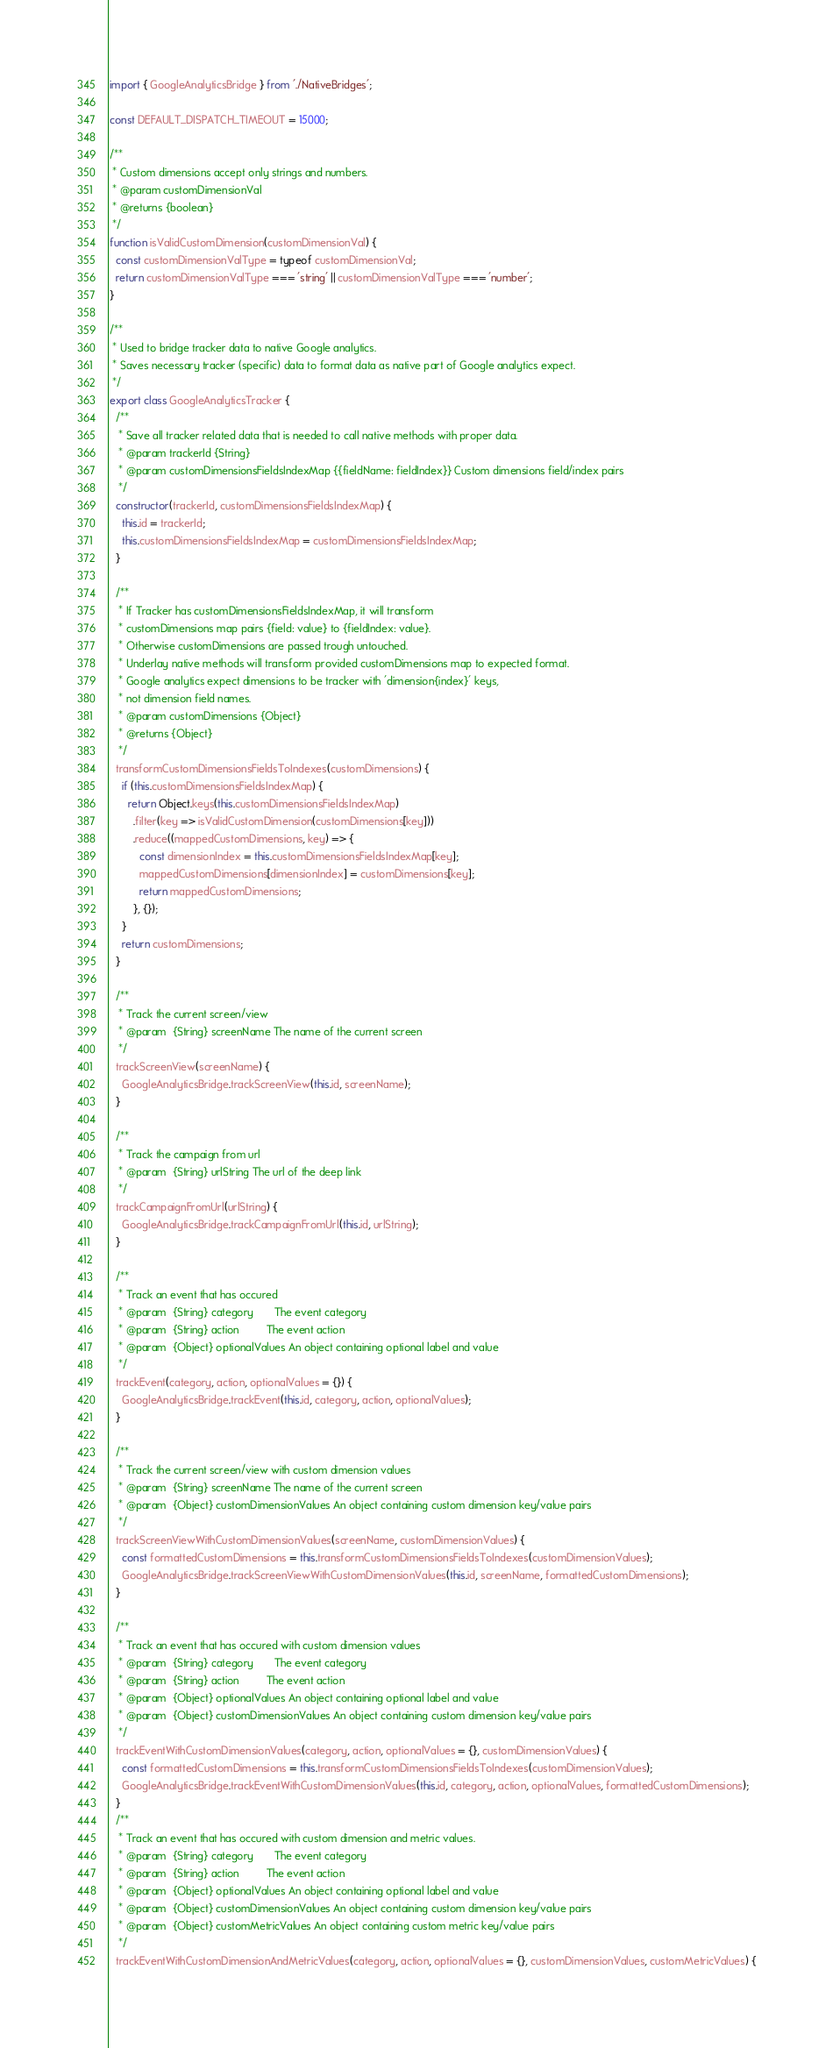Convert code to text. <code><loc_0><loc_0><loc_500><loc_500><_JavaScript_>import { GoogleAnalyticsBridge } from './NativeBridges';

const DEFAULT_DISPATCH_TIMEOUT = 15000;

/**
 * Custom dimensions accept only strings and numbers.
 * @param customDimensionVal
 * @returns {boolean}
 */
function isValidCustomDimension(customDimensionVal) {
  const customDimensionValType = typeof customDimensionVal;
  return customDimensionValType === 'string' || customDimensionValType === 'number';
}

/**
 * Used to bridge tracker data to native Google analytics.
 * Saves necessary tracker (specific) data to format data as native part of Google analytics expect.
 */
export class GoogleAnalyticsTracker {
  /**
   * Save all tracker related data that is needed to call native methods with proper data.
   * @param trackerId {String}
   * @param customDimensionsFieldsIndexMap {{fieldName: fieldIndex}} Custom dimensions field/index pairs
   */
  constructor(trackerId, customDimensionsFieldsIndexMap) {
    this.id = trackerId;
    this.customDimensionsFieldsIndexMap = customDimensionsFieldsIndexMap;
  }

  /**
   * If Tracker has customDimensionsFieldsIndexMap, it will transform
   * customDimensions map pairs {field: value} to {fieldIndex: value}.
   * Otherwise customDimensions are passed trough untouched.
   * Underlay native methods will transform provided customDimensions map to expected format.
   * Google analytics expect dimensions to be tracker with 'dimension{index}' keys,
   * not dimension field names.
   * @param customDimensions {Object}
   * @returns {Object}
   */
  transformCustomDimensionsFieldsToIndexes(customDimensions) {
    if (this.customDimensionsFieldsIndexMap) {
      return Object.keys(this.customDimensionsFieldsIndexMap)
        .filter(key => isValidCustomDimension(customDimensions[key]))
        .reduce((mappedCustomDimensions, key) => {
          const dimensionIndex = this.customDimensionsFieldsIndexMap[key];
          mappedCustomDimensions[dimensionIndex] = customDimensions[key];
          return mappedCustomDimensions;
        }, {});
    }
    return customDimensions;
  }

  /**
   * Track the current screen/view
   * @param  {String} screenName The name of the current screen
   */
  trackScreenView(screenName) {
    GoogleAnalyticsBridge.trackScreenView(this.id, screenName);
  }

  /**
   * Track the campaign from url
   * @param  {String} urlString The url of the deep link
   */
  trackCampaignFromUrl(urlString) {
    GoogleAnalyticsBridge.trackCampaignFromUrl(this.id, urlString);
  }

  /**
   * Track an event that has occured
   * @param  {String} category       The event category
   * @param  {String} action         The event action
   * @param  {Object} optionalValues An object containing optional label and value
   */
  trackEvent(category, action, optionalValues = {}) {
    GoogleAnalyticsBridge.trackEvent(this.id, category, action, optionalValues);
  }

  /**
   * Track the current screen/view with custom dimension values
   * @param  {String} screenName The name of the current screen
   * @param  {Object} customDimensionValues An object containing custom dimension key/value pairs
   */
  trackScreenViewWithCustomDimensionValues(screenName, customDimensionValues) {
    const formattedCustomDimensions = this.transformCustomDimensionsFieldsToIndexes(customDimensionValues);
    GoogleAnalyticsBridge.trackScreenViewWithCustomDimensionValues(this.id, screenName, formattedCustomDimensions);
  }

  /**
   * Track an event that has occured with custom dimension values
   * @param  {String} category       The event category
   * @param  {String} action         The event action
   * @param  {Object} optionalValues An object containing optional label and value
   * @param  {Object} customDimensionValues An object containing custom dimension key/value pairs
   */
  trackEventWithCustomDimensionValues(category, action, optionalValues = {}, customDimensionValues) {
    const formattedCustomDimensions = this.transformCustomDimensionsFieldsToIndexes(customDimensionValues);
    GoogleAnalyticsBridge.trackEventWithCustomDimensionValues(this.id, category, action, optionalValues, formattedCustomDimensions);
  }
  /**
   * Track an event that has occured with custom dimension and metric values.
   * @param  {String} category       The event category
   * @param  {String} action         The event action
   * @param  {Object} optionalValues An object containing optional label and value
   * @param  {Object} customDimensionValues An object containing custom dimension key/value pairs
   * @param  {Object} customMetricValues An object containing custom metric key/value pairs
   */
  trackEventWithCustomDimensionAndMetricValues(category, action, optionalValues = {}, customDimensionValues, customMetricValues) {</code> 